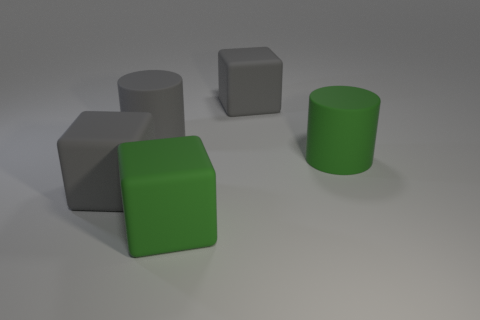Subtract all big gray rubber cubes. How many cubes are left? 1 Subtract 1 blocks. How many blocks are left? 2 Add 1 yellow matte spheres. How many objects exist? 6 Subtract all cylinders. How many objects are left? 3 Subtract all big gray objects. Subtract all cylinders. How many objects are left? 0 Add 5 gray cylinders. How many gray cylinders are left? 6 Add 5 green cylinders. How many green cylinders exist? 6 Subtract 0 purple cubes. How many objects are left? 5 